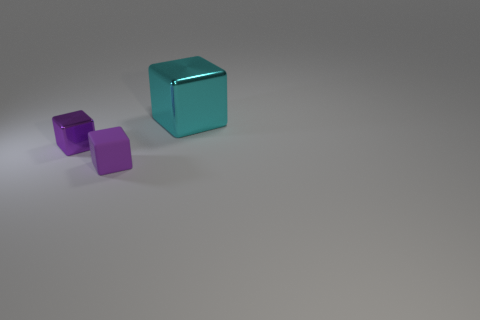There is a object that is the same color as the small matte cube; what is its material?
Offer a terse response. Metal. What number of other things are there of the same color as the tiny metal block?
Your answer should be compact. 1. There is a metallic thing on the left side of the big block; is its size the same as the cube that is behind the small metal thing?
Provide a short and direct response. No. Are there an equal number of purple shiny things behind the matte cube and small purple rubber blocks that are behind the big cyan metal object?
Provide a succinct answer. No. There is a purple shiny cube; is it the same size as the cube in front of the tiny purple metallic cube?
Offer a very short reply. Yes. What material is the purple object behind the thing in front of the tiny shiny thing?
Provide a succinct answer. Metal. Are there an equal number of tiny matte objects that are behind the big cyan metallic object and tiny metal blocks?
Offer a terse response. No. What is the size of the object that is both right of the purple metal block and behind the purple matte block?
Provide a succinct answer. Large. What color is the block in front of the shiny cube in front of the large cyan shiny block?
Your response must be concise. Purple. How many brown objects are big blocks or metallic blocks?
Ensure brevity in your answer.  0. 